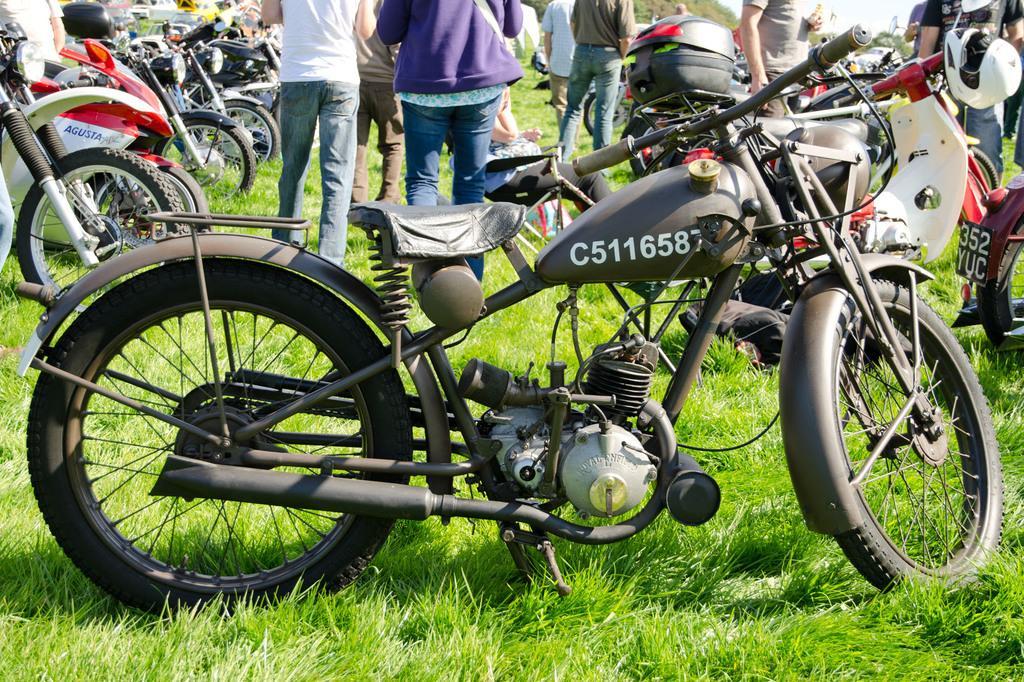Describe this image in one or two sentences. In this image I can see bicycles and few people are walking. 